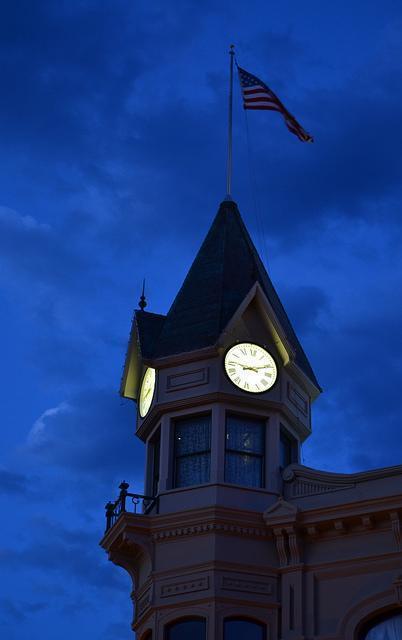How many clocks are there?
Give a very brief answer. 2. 